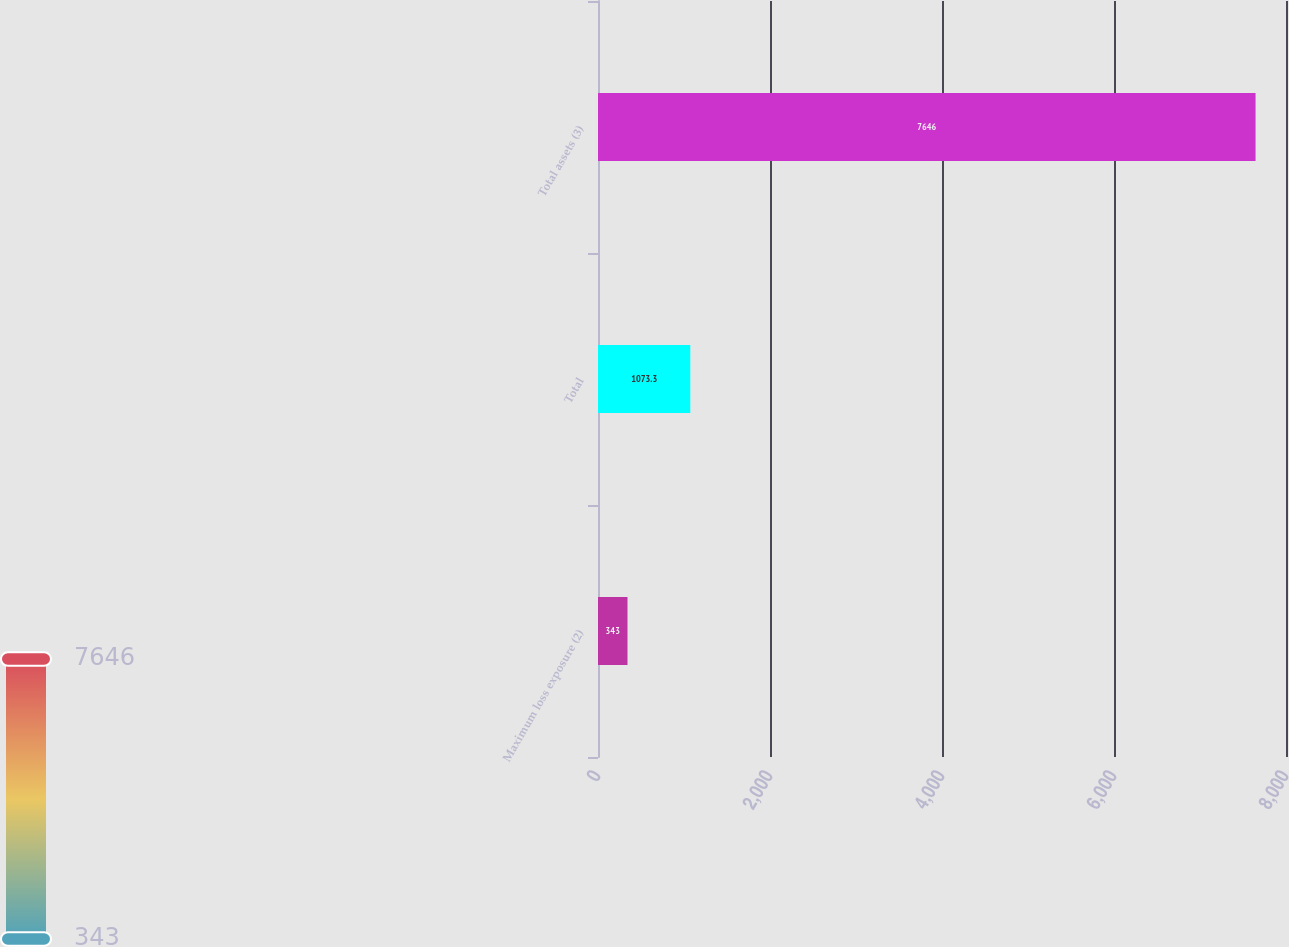Convert chart to OTSL. <chart><loc_0><loc_0><loc_500><loc_500><bar_chart><fcel>Maximum loss exposure (2)<fcel>Total<fcel>Total assets (3)<nl><fcel>343<fcel>1073.3<fcel>7646<nl></chart> 